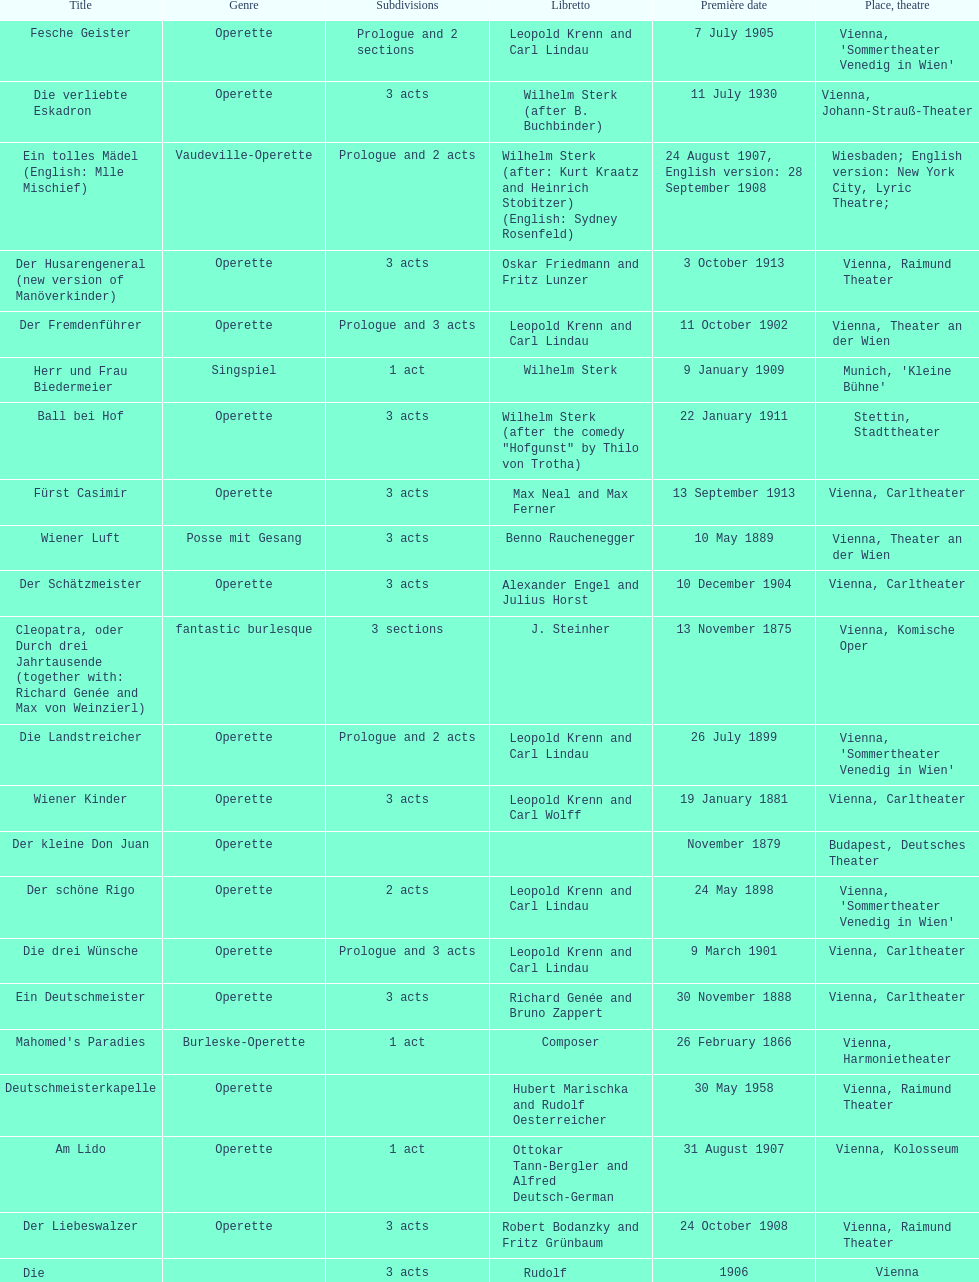Which year did he release his last operetta? 1930. 